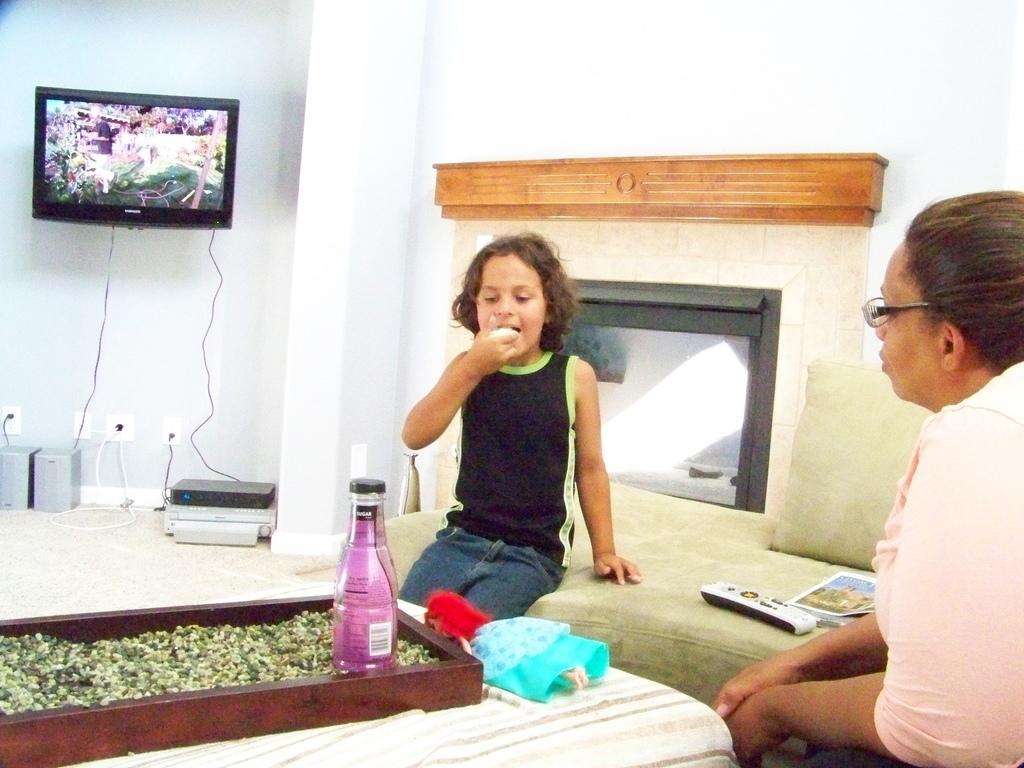Could you give a brief overview of what you see in this image? In this image we can see a child wearing black dress is eating something and we can see a woman are sitting on the sofa. Here we can see a bottle and a doll kept here also we can see the remote controller and a book kept here. In the background, we can see television, speakers and CD players here. Here we can see the fireplace. 